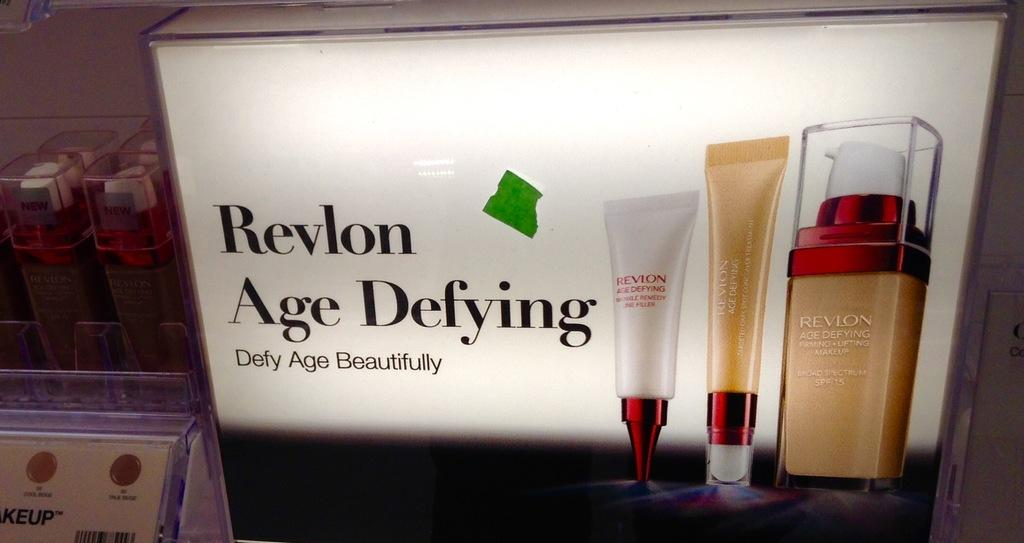<image>
Share a concise interpretation of the image provided. ad poster for revolon age defying makeup foundation 